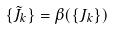Convert formula to latex. <formula><loc_0><loc_0><loc_500><loc_500>\{ \tilde { J } _ { k } \} = \beta ( \{ J _ { k } \} )</formula> 